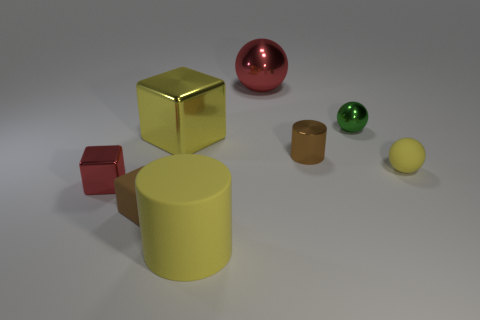There is a tiny yellow rubber thing; is it the same shape as the tiny shiny object that is behind the yellow cube?
Offer a terse response. Yes. The other shiny thing that is the same shape as the yellow metallic thing is what size?
Make the answer very short. Small. What number of other things are there of the same material as the small green ball
Your answer should be very brief. 4. What is the material of the brown block?
Give a very brief answer. Rubber. Does the small matte object to the right of the tiny brown matte cube have the same color as the big thing in front of the brown rubber thing?
Keep it short and to the point. Yes. Are there more large metallic things in front of the green object than large matte spheres?
Give a very brief answer. Yes. What number of other things are the same color as the small metallic sphere?
Your answer should be very brief. 0. Does the metallic cube in front of the yellow metallic cube have the same size as the small brown rubber block?
Offer a very short reply. Yes. Is there a gray shiny object of the same size as the rubber block?
Ensure brevity in your answer.  No. What is the color of the small rubber object left of the yellow cylinder?
Offer a very short reply. Brown. 